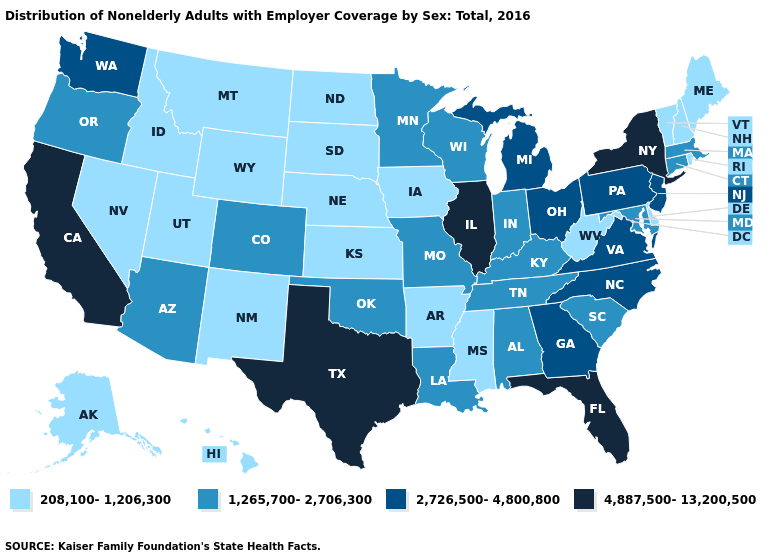Which states have the lowest value in the USA?
Quick response, please. Alaska, Arkansas, Delaware, Hawaii, Idaho, Iowa, Kansas, Maine, Mississippi, Montana, Nebraska, Nevada, New Hampshire, New Mexico, North Dakota, Rhode Island, South Dakota, Utah, Vermont, West Virginia, Wyoming. What is the value of Wyoming?
Give a very brief answer. 208,100-1,206,300. What is the highest value in the USA?
Concise answer only. 4,887,500-13,200,500. Does the first symbol in the legend represent the smallest category?
Keep it brief. Yes. Among the states that border Virginia , does Tennessee have the highest value?
Quick response, please. No. Does the first symbol in the legend represent the smallest category?
Keep it brief. Yes. Does South Dakota have the lowest value in the MidWest?
Write a very short answer. Yes. What is the lowest value in states that border Oregon?
Answer briefly. 208,100-1,206,300. Which states have the lowest value in the USA?
Answer briefly. Alaska, Arkansas, Delaware, Hawaii, Idaho, Iowa, Kansas, Maine, Mississippi, Montana, Nebraska, Nevada, New Hampshire, New Mexico, North Dakota, Rhode Island, South Dakota, Utah, Vermont, West Virginia, Wyoming. What is the value of New York?
Answer briefly. 4,887,500-13,200,500. What is the value of North Carolina?
Short answer required. 2,726,500-4,800,800. Does Delaware have the same value as Hawaii?
Keep it brief. Yes. What is the lowest value in the USA?
Give a very brief answer. 208,100-1,206,300. Which states have the lowest value in the USA?
Quick response, please. Alaska, Arkansas, Delaware, Hawaii, Idaho, Iowa, Kansas, Maine, Mississippi, Montana, Nebraska, Nevada, New Hampshire, New Mexico, North Dakota, Rhode Island, South Dakota, Utah, Vermont, West Virginia, Wyoming. Does Wisconsin have a higher value than Missouri?
Concise answer only. No. 